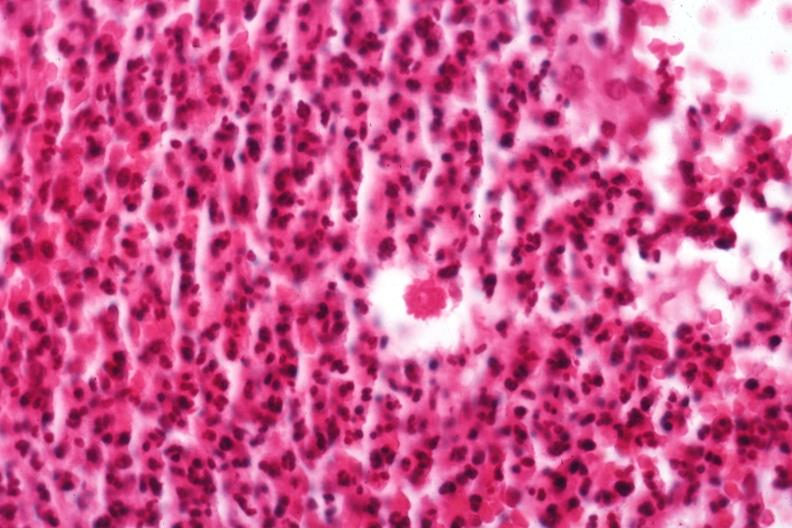does chronic myelogenous leukemia show organism?
Answer the question using a single word or phrase. No 